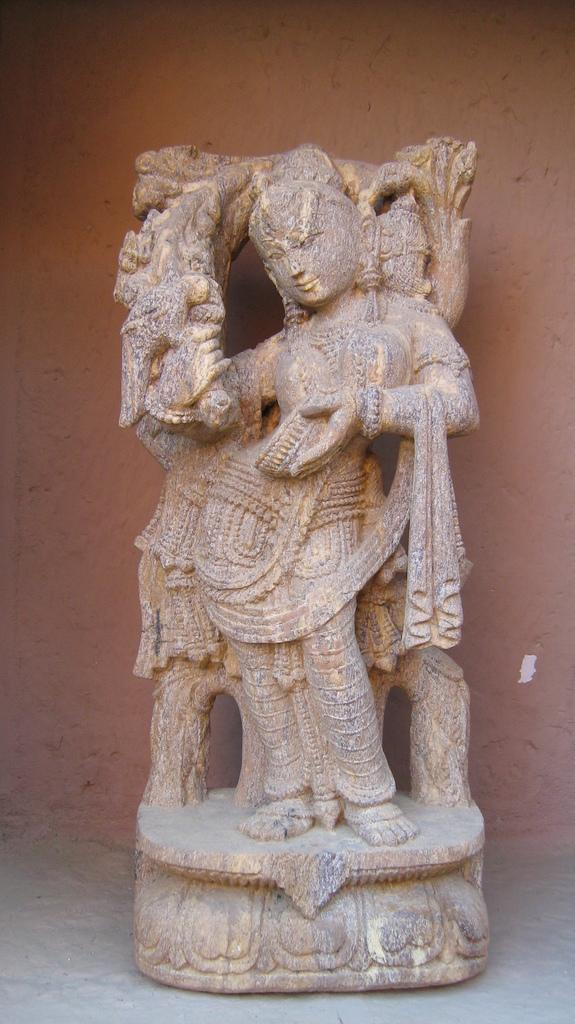What is the main subject in the center of the image? There is a statue in the center of the image. Where is the statue located? The statue is on the floor. What can be seen in the background of the image? There is a wall in the background of the image. How many eyes does the statue have in the image? The image does not provide information about the number of eyes on the statue, as it only shows the statue's overall appearance and location. 